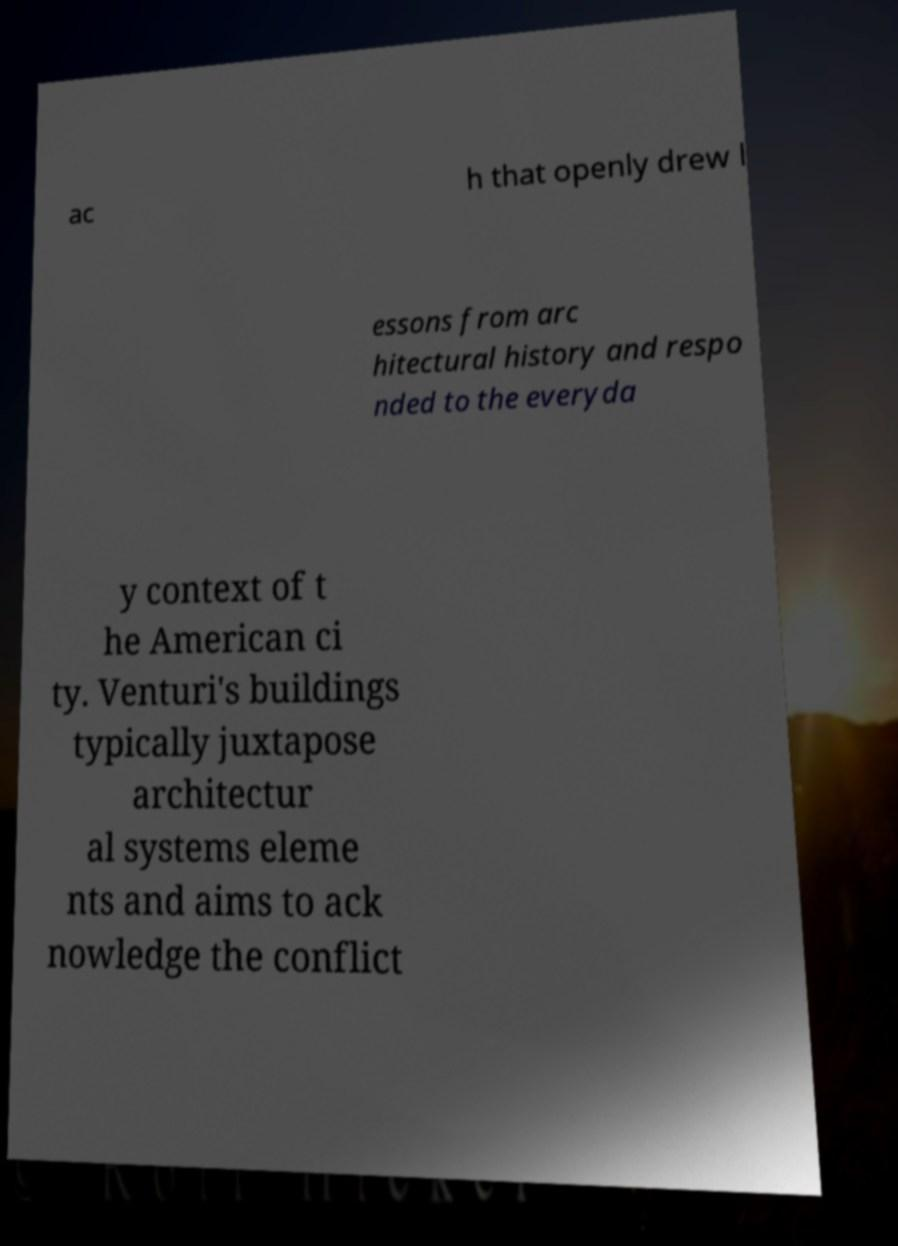Could you extract and type out the text from this image? ac h that openly drew l essons from arc hitectural history and respo nded to the everyda y context of t he American ci ty. Venturi's buildings typically juxtapose architectur al systems eleme nts and aims to ack nowledge the conflict 